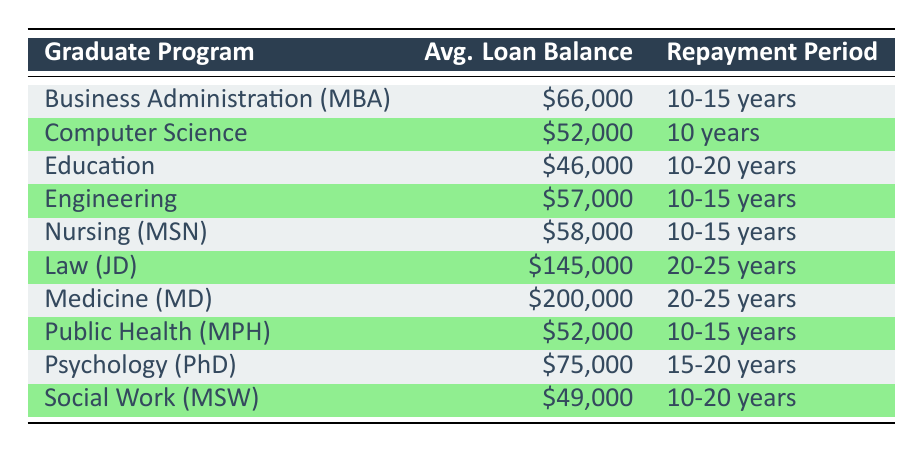What is the average loan balance for graduates in Education? The table shows that the average loan balance for graduates in Education is listed as $46,000.
Answer: $46,000 Which program has the highest average loan balance? According to the table, the program with the highest average loan balance is Medicine (MD) with $200,000.
Answer: Medicine (MD) What is the repayment period for Psychology (PhD)? The repayment period for Psychology (PhD) is detailed in the table as 15-20 years.
Answer: 15-20 years Is the average loan balance for Law (JD) more than double that of Nursing (MSN)? The average loan balance for Law (JD) is $145,000 and for Nursing (MSN) it is $58,000. Doubling the Nursing loan balance results in $116,000, which is less than $145,000, so the statement is true.
Answer: Yes What is the average loan balance for the group of majors with the highest repayment period, which is 20-25 years? The majors with a repayment period of 20-25 years are Law (JD) and Medicine (MD) with average loan balances of $145,000 and $200,000, respectively. Their average is calculated as follows: (145,000 + 200,000) / 2 = 172,500.
Answer: $172,500 Which major has a loan balance between $50,000 and $60,000, and what is its repayment period? Looking at the table, both Nursing (MSN) and Public Health (MPH) have loan balances within that range, specifically $58,000 and $52,000 respectively. Their repayment periods are both 10-15 years.
Answer: Nursing (MSN) and Public Health (MPH), repayment period: 10-15 years Is it true that all majors with an average loan balance below $60,000 have shorter repayment periods than those with balances above $100,000? The majors below $60,000 are Education, Social Work, Public Health, Computer Science, and Engineering, with repayment periods of 10-20 years or 10 years. In contrast, those above $100,000 (Law and Medicine) have repayment periods of 20-25 years. Thus, the statement is true.
Answer: Yes What is the median average loan balance among the listed graduate programs? To find the median, we order the average loan balances: $46,000, $49,000, $52,000, $52,000, $57,000, $58,000, $66,000, $75,000, $145,000, $200,000. The middle values are $58,000 and $66,000, leading to a median of (58,000 + 66,000) / 2 = $62,000.
Answer: $62,000 Which program's average loan balance difference is greater than $10,000 when compared to the average loan balance of Computer Science? The average loan balance for Computer Science is $52,000. Programs with a difference greater than $10,000 include Business Administration (MBA) at $66,000 and Psychology (PhD) at $75,000. Calculating, Business Administration has a difference of $14,000 and Psychology a difference of $23,000, both are greater than $10,000.
Answer: Business Administration (MBA) and Psychology (PhD) 